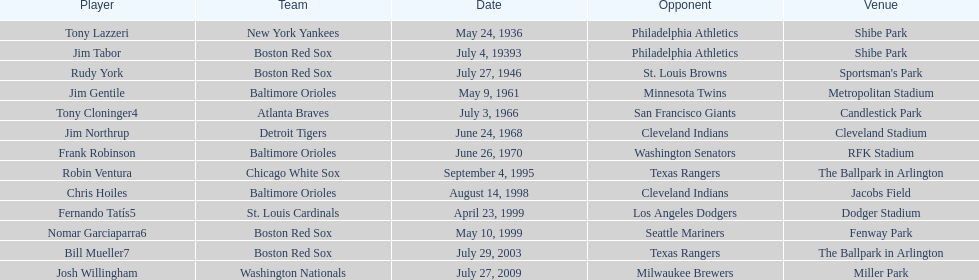On july 27, 1946, which team faced off against the boston red sox? St. Louis Browns. 